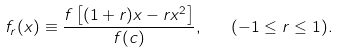<formula> <loc_0><loc_0><loc_500><loc_500>f _ { r } ( x ) \equiv \frac { f \left [ ( 1 + r ) x - r x ^ { 2 } \right ] } { f ( c ) } , \quad ( - 1 \leq r \leq 1 ) .</formula> 